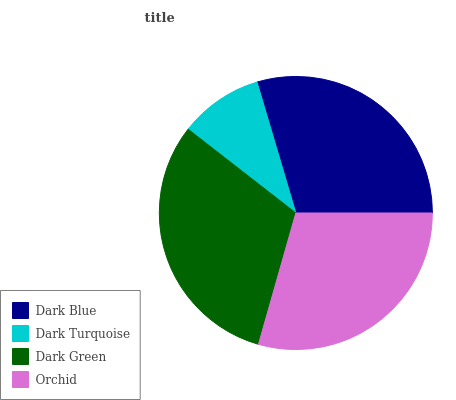Is Dark Turquoise the minimum?
Answer yes or no. Yes. Is Dark Green the maximum?
Answer yes or no. Yes. Is Dark Green the minimum?
Answer yes or no. No. Is Dark Turquoise the maximum?
Answer yes or no. No. Is Dark Green greater than Dark Turquoise?
Answer yes or no. Yes. Is Dark Turquoise less than Dark Green?
Answer yes or no. Yes. Is Dark Turquoise greater than Dark Green?
Answer yes or no. No. Is Dark Green less than Dark Turquoise?
Answer yes or no. No. Is Dark Blue the high median?
Answer yes or no. Yes. Is Orchid the low median?
Answer yes or no. Yes. Is Dark Turquoise the high median?
Answer yes or no. No. Is Dark Green the low median?
Answer yes or no. No. 